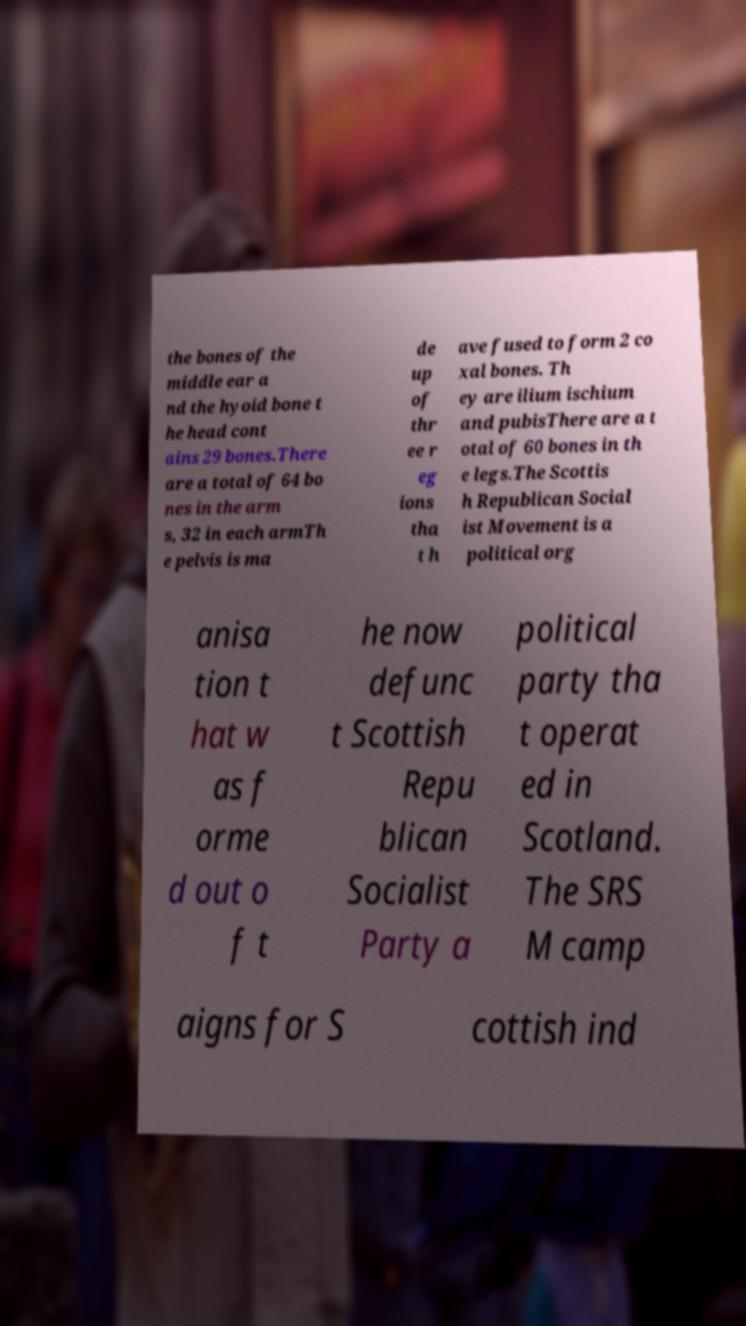Can you read and provide the text displayed in the image?This photo seems to have some interesting text. Can you extract and type it out for me? the bones of the middle ear a nd the hyoid bone t he head cont ains 29 bones.There are a total of 64 bo nes in the arm s, 32 in each armTh e pelvis is ma de up of thr ee r eg ions tha t h ave fused to form 2 co xal bones. Th ey are ilium ischium and pubisThere are a t otal of 60 bones in th e legs.The Scottis h Republican Social ist Movement is a political org anisa tion t hat w as f orme d out o f t he now defunc t Scottish Repu blican Socialist Party a political party tha t operat ed in Scotland. The SRS M camp aigns for S cottish ind 